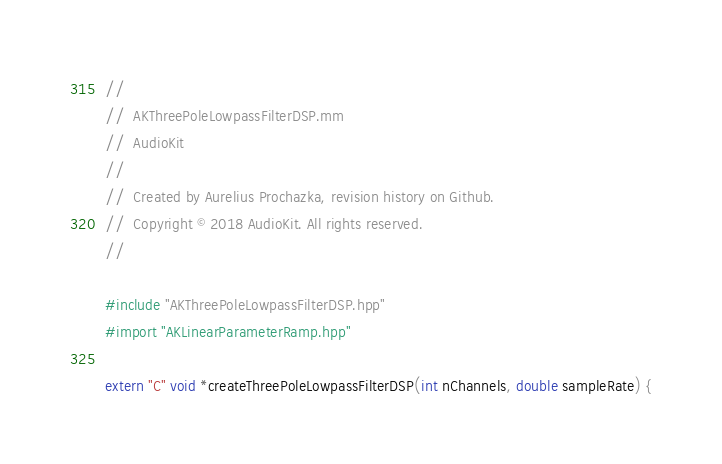Convert code to text. <code><loc_0><loc_0><loc_500><loc_500><_ObjectiveC_>//
//  AKThreePoleLowpassFilterDSP.mm
//  AudioKit
//
//  Created by Aurelius Prochazka, revision history on Github.
//  Copyright © 2018 AudioKit. All rights reserved.
//

#include "AKThreePoleLowpassFilterDSP.hpp"
#import "AKLinearParameterRamp.hpp"

extern "C" void *createThreePoleLowpassFilterDSP(int nChannels, double sampleRate) {</code> 